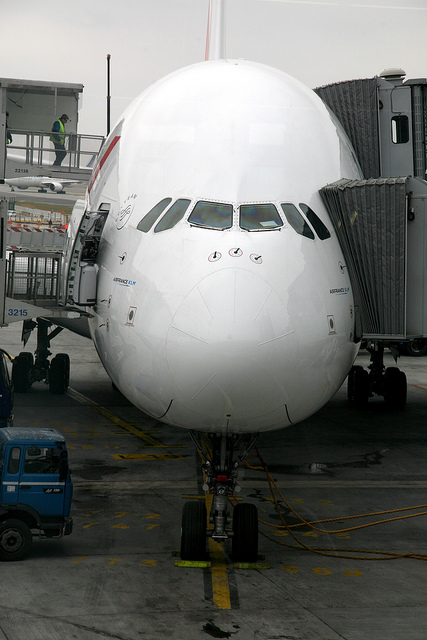<image>Is the plane about to take off? I am not sure if the plane is about to take off. Is the plane about to take off? I don't know if the plane is about to take off. 